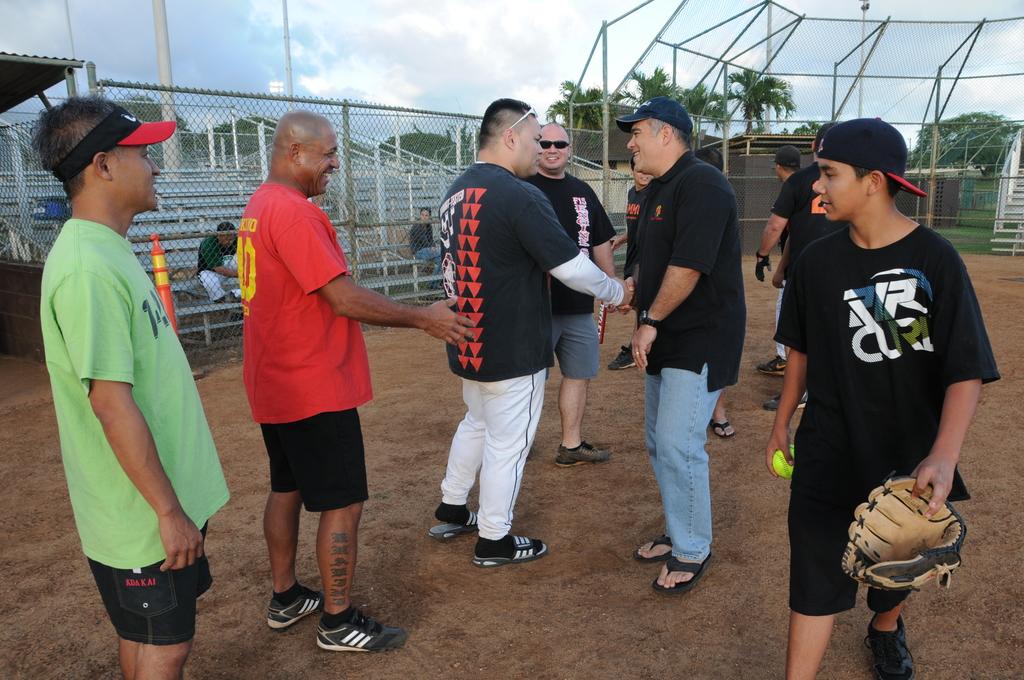What is the brand of black shirt?
Your response must be concise. Rr curi. 